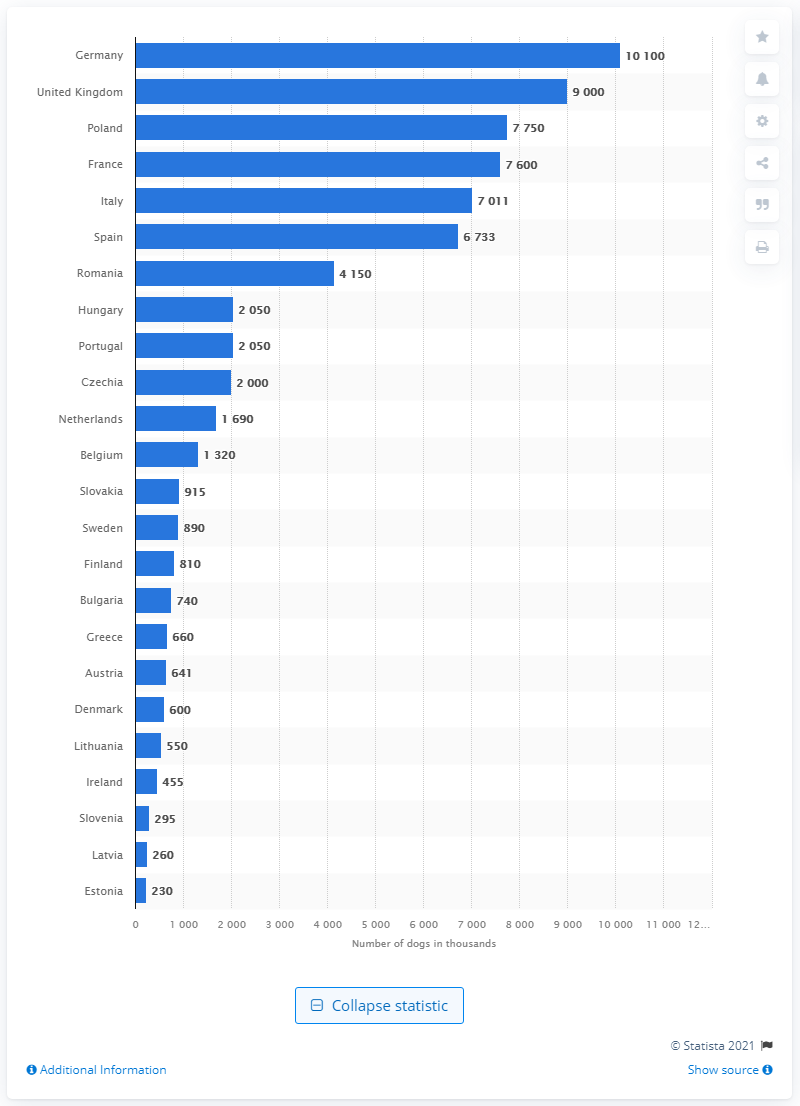Give some essential details in this illustration. According to statistics, Germany had the highest dog population in the European Union in 2019. 